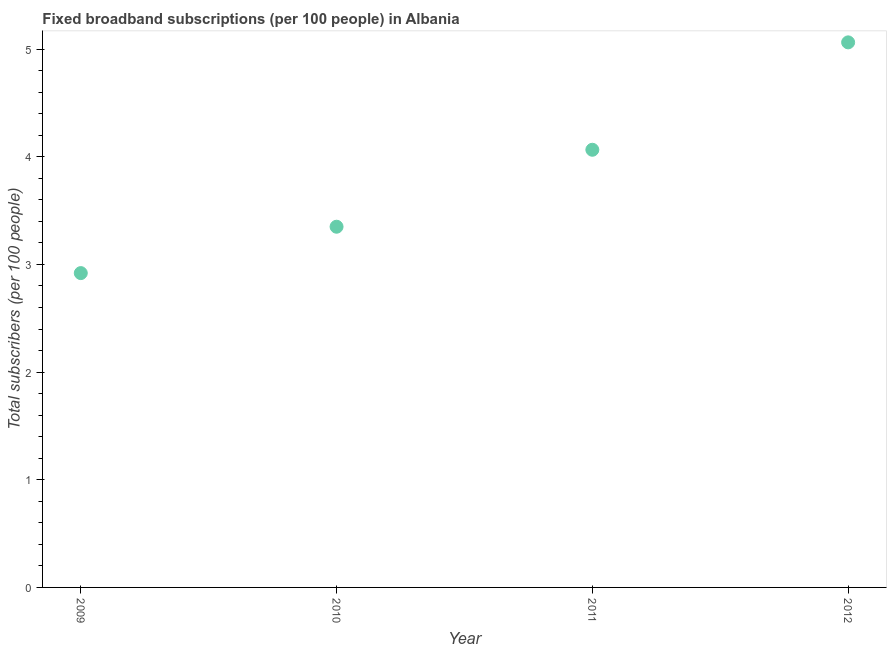What is the total number of fixed broadband subscriptions in 2010?
Your answer should be very brief. 3.35. Across all years, what is the maximum total number of fixed broadband subscriptions?
Ensure brevity in your answer.  5.06. Across all years, what is the minimum total number of fixed broadband subscriptions?
Your response must be concise. 2.92. In which year was the total number of fixed broadband subscriptions maximum?
Provide a succinct answer. 2012. In which year was the total number of fixed broadband subscriptions minimum?
Offer a terse response. 2009. What is the sum of the total number of fixed broadband subscriptions?
Keep it short and to the point. 15.4. What is the difference between the total number of fixed broadband subscriptions in 2010 and 2011?
Your answer should be compact. -0.71. What is the average total number of fixed broadband subscriptions per year?
Offer a very short reply. 3.85. What is the median total number of fixed broadband subscriptions?
Ensure brevity in your answer.  3.71. What is the ratio of the total number of fixed broadband subscriptions in 2010 to that in 2012?
Provide a succinct answer. 0.66. Is the difference between the total number of fixed broadband subscriptions in 2010 and 2012 greater than the difference between any two years?
Ensure brevity in your answer.  No. What is the difference between the highest and the second highest total number of fixed broadband subscriptions?
Make the answer very short. 1. Is the sum of the total number of fixed broadband subscriptions in 2009 and 2010 greater than the maximum total number of fixed broadband subscriptions across all years?
Make the answer very short. Yes. What is the difference between the highest and the lowest total number of fixed broadband subscriptions?
Your answer should be very brief. 2.14. In how many years, is the total number of fixed broadband subscriptions greater than the average total number of fixed broadband subscriptions taken over all years?
Provide a short and direct response. 2. Does the total number of fixed broadband subscriptions monotonically increase over the years?
Your response must be concise. Yes. What is the difference between two consecutive major ticks on the Y-axis?
Your response must be concise. 1. Does the graph contain grids?
Ensure brevity in your answer.  No. What is the title of the graph?
Give a very brief answer. Fixed broadband subscriptions (per 100 people) in Albania. What is the label or title of the X-axis?
Offer a terse response. Year. What is the label or title of the Y-axis?
Provide a succinct answer. Total subscribers (per 100 people). What is the Total subscribers (per 100 people) in 2009?
Give a very brief answer. 2.92. What is the Total subscribers (per 100 people) in 2010?
Provide a succinct answer. 3.35. What is the Total subscribers (per 100 people) in 2011?
Your answer should be compact. 4.07. What is the Total subscribers (per 100 people) in 2012?
Ensure brevity in your answer.  5.06. What is the difference between the Total subscribers (per 100 people) in 2009 and 2010?
Offer a very short reply. -0.43. What is the difference between the Total subscribers (per 100 people) in 2009 and 2011?
Offer a terse response. -1.15. What is the difference between the Total subscribers (per 100 people) in 2009 and 2012?
Your answer should be compact. -2.14. What is the difference between the Total subscribers (per 100 people) in 2010 and 2011?
Provide a short and direct response. -0.71. What is the difference between the Total subscribers (per 100 people) in 2010 and 2012?
Provide a succinct answer. -1.71. What is the difference between the Total subscribers (per 100 people) in 2011 and 2012?
Your response must be concise. -1. What is the ratio of the Total subscribers (per 100 people) in 2009 to that in 2010?
Offer a terse response. 0.87. What is the ratio of the Total subscribers (per 100 people) in 2009 to that in 2011?
Keep it short and to the point. 0.72. What is the ratio of the Total subscribers (per 100 people) in 2009 to that in 2012?
Keep it short and to the point. 0.58. What is the ratio of the Total subscribers (per 100 people) in 2010 to that in 2011?
Make the answer very short. 0.82. What is the ratio of the Total subscribers (per 100 people) in 2010 to that in 2012?
Your answer should be very brief. 0.66. What is the ratio of the Total subscribers (per 100 people) in 2011 to that in 2012?
Offer a terse response. 0.8. 